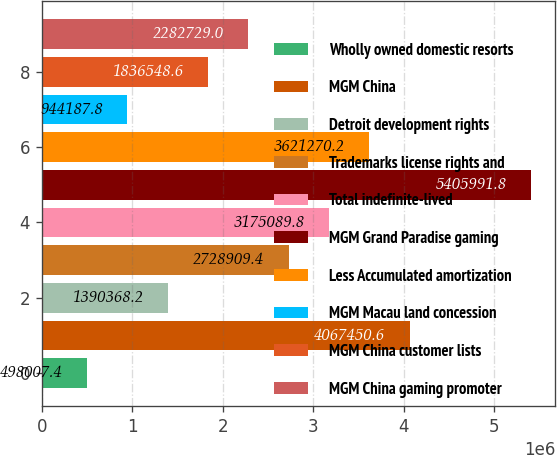<chart> <loc_0><loc_0><loc_500><loc_500><bar_chart><fcel>Wholly owned domestic resorts<fcel>MGM China<fcel>Detroit development rights<fcel>Trademarks license rights and<fcel>Total indefinite-lived<fcel>MGM Grand Paradise gaming<fcel>Less Accumulated amortization<fcel>MGM Macau land concession<fcel>MGM China customer lists<fcel>MGM China gaming promoter<nl><fcel>498007<fcel>4.06745e+06<fcel>1.39037e+06<fcel>2.72891e+06<fcel>3.17509e+06<fcel>5.40599e+06<fcel>3.62127e+06<fcel>944188<fcel>1.83655e+06<fcel>2.28273e+06<nl></chart> 